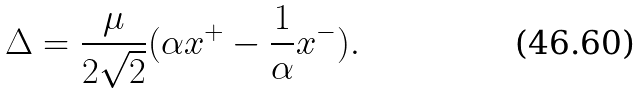Convert formula to latex. <formula><loc_0><loc_0><loc_500><loc_500>\Delta = \frac { \mu } { 2 \sqrt { 2 } } ( \alpha x ^ { + } - \frac { 1 } { \alpha } x ^ { - } ) .</formula> 